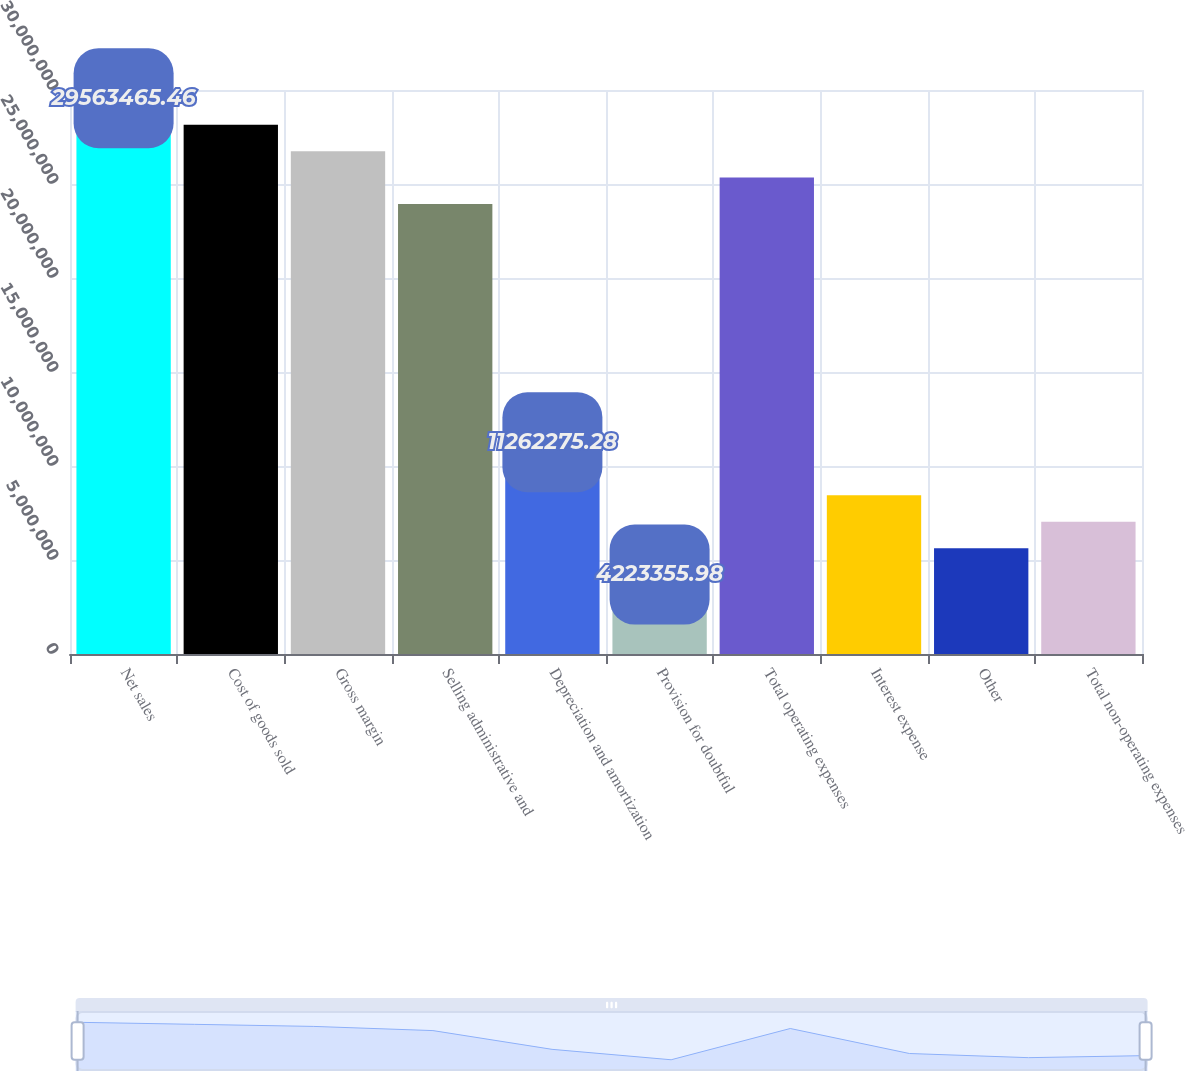Convert chart to OTSL. <chart><loc_0><loc_0><loc_500><loc_500><bar_chart><fcel>Net sales<fcel>Cost of goods sold<fcel>Gross margin<fcel>Selling administrative and<fcel>Depreciation and amortization<fcel>Provision for doubtful<fcel>Total operating expenses<fcel>Interest expense<fcel>Other<fcel>Total non-operating expenses<nl><fcel>2.95635e+07<fcel>2.81557e+07<fcel>2.67479e+07<fcel>2.39323e+07<fcel>1.12623e+07<fcel>4.22336e+06<fcel>2.53401e+07<fcel>8.44671e+06<fcel>5.63114e+06<fcel>7.03892e+06<nl></chart> 